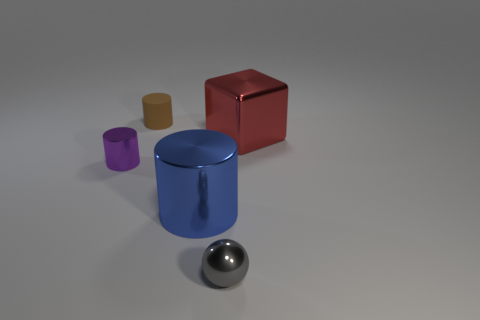Do the thing behind the metal cube and the object in front of the blue metal thing have the same size? Although it may appear that the cylinder behind the metallic cube and the sphere in front of the blue cylindrical object have similar sizes, perspective can distort actual dimensions. Without accurate measurements, we cannot ascertain if they are indeed the same size. 